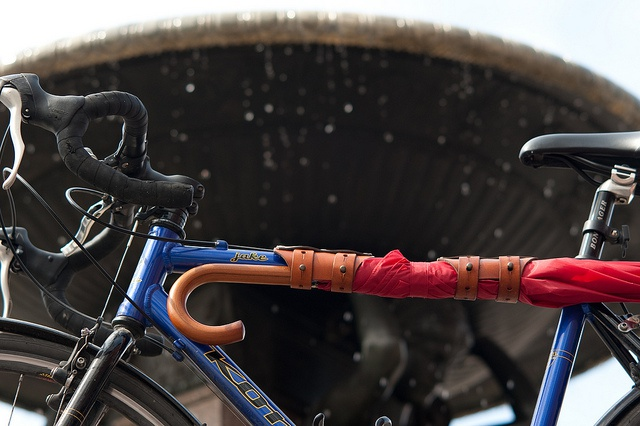Describe the objects in this image and their specific colors. I can see bicycle in white, black, maroon, and gray tones, umbrella in white, black, gray, and maroon tones, and umbrella in white, maroon, brown, black, and salmon tones in this image. 